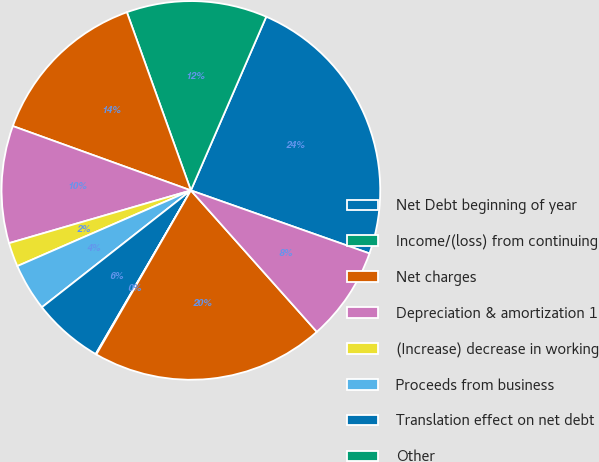Convert chart to OTSL. <chart><loc_0><loc_0><loc_500><loc_500><pie_chart><fcel>Net Debt beginning of year<fcel>Income/(loss) from continuing<fcel>Net charges<fcel>Depreciation & amortization 1<fcel>(Increase) decrease in working<fcel>Proceeds from business<fcel>Translation effect on net debt<fcel>Other<fcel>Net Debt end of year<fcel>Bank loans and current portion<nl><fcel>23.88%<fcel>12.0%<fcel>13.99%<fcel>10.01%<fcel>2.05%<fcel>4.04%<fcel>6.03%<fcel>0.06%<fcel>19.9%<fcel>8.02%<nl></chart> 